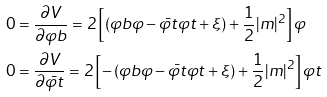Convert formula to latex. <formula><loc_0><loc_0><loc_500><loc_500>0 & = \frac { \partial V } { \partial \varphi b } = 2 \left [ \left ( \varphi b \varphi - \bar { \varphi t } \varphi t + \xi \right ) + \frac { 1 } { 2 } | m | ^ { 2 } \right ] \varphi \\ 0 & = \frac { \partial V } { \partial \bar { \varphi t } } = 2 \left [ - \left ( \varphi b \varphi - \bar { \varphi t } \varphi t + \xi \right ) + \frac { 1 } { 2 } | m | ^ { 2 } \right ] \varphi t</formula> 